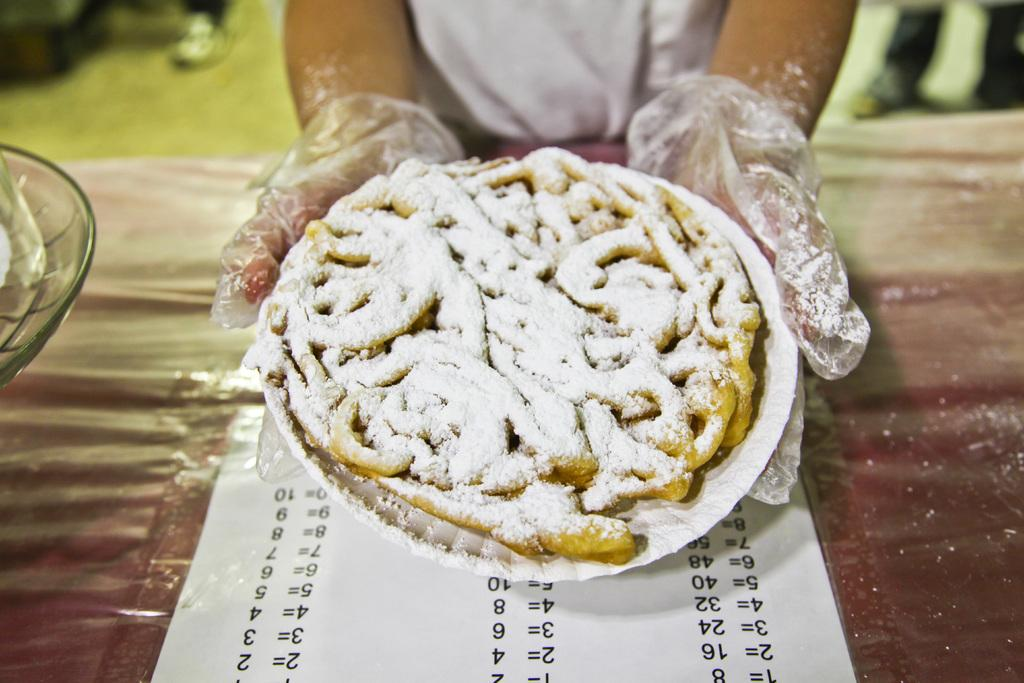What is on the paper plate in the image? There is food on a paper plate in the image. What other dish is present in the image? There is a bowl in the image. What object is on a platform in the image? There is a paper on a platform in the image. Can you describe the person's hands in the background? In the background, a person's hands are holding a paper plate. What type of air is being used to cool the food on the paper plate? There is no mention of air or cooling in the image, so it cannot be determined. Is there a school visible in the background of the image? There is no indication of a school or any educational institution in the image. 